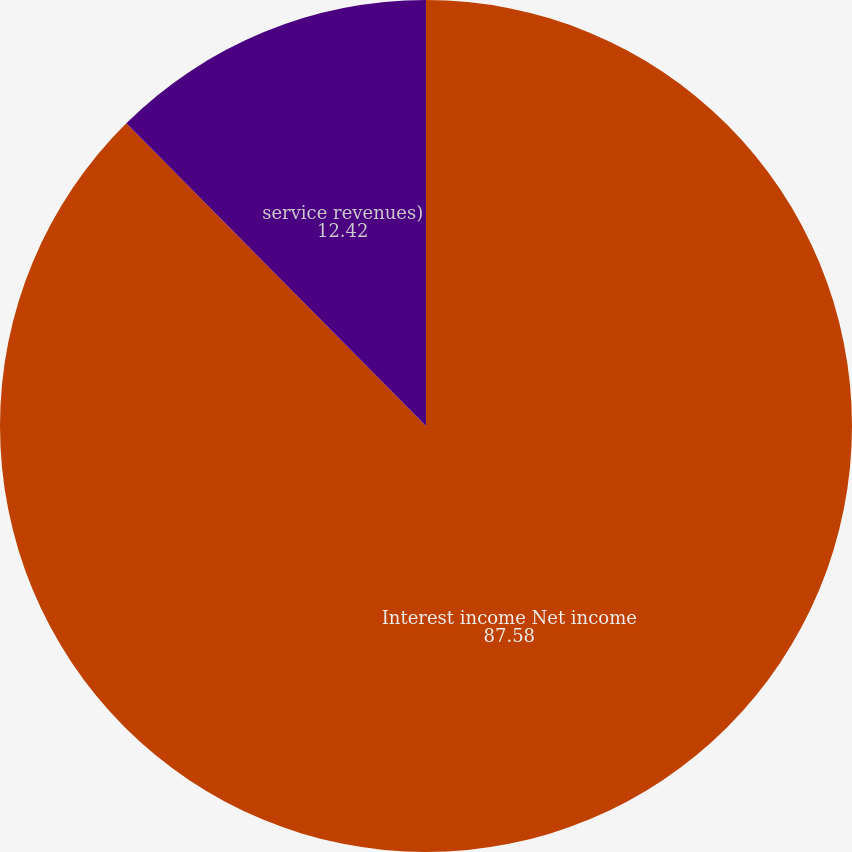<chart> <loc_0><loc_0><loc_500><loc_500><pie_chart><fcel>Interest income Net income<fcel>service revenues)<nl><fcel>87.58%<fcel>12.42%<nl></chart> 